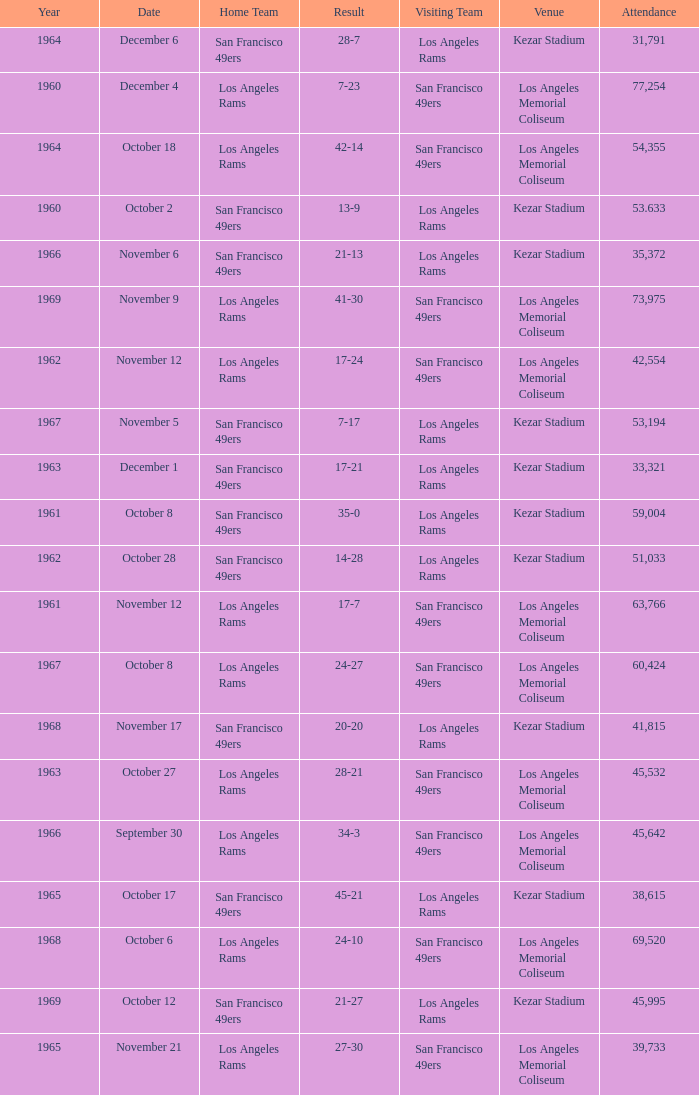When the san francisco 49ers are visiting with an attendance of more than 45,532 on September 30, who was the home team? Los Angeles Rams. Would you be able to parse every entry in this table? {'header': ['Year', 'Date', 'Home Team', 'Result', 'Visiting Team', 'Venue', 'Attendance'], 'rows': [['1964', 'December 6', 'San Francisco 49ers', '28-7', 'Los Angeles Rams', 'Kezar Stadium', '31,791'], ['1960', 'December 4', 'Los Angeles Rams', '7-23', 'San Francisco 49ers', 'Los Angeles Memorial Coliseum', '77,254'], ['1964', 'October 18', 'Los Angeles Rams', '42-14', 'San Francisco 49ers', 'Los Angeles Memorial Coliseum', '54,355'], ['1960', 'October 2', 'San Francisco 49ers', '13-9', 'Los Angeles Rams', 'Kezar Stadium', '53.633'], ['1966', 'November 6', 'San Francisco 49ers', '21-13', 'Los Angeles Rams', 'Kezar Stadium', '35,372'], ['1969', 'November 9', 'Los Angeles Rams', '41-30', 'San Francisco 49ers', 'Los Angeles Memorial Coliseum', '73,975'], ['1962', 'November 12', 'Los Angeles Rams', '17-24', 'San Francisco 49ers', 'Los Angeles Memorial Coliseum', '42,554'], ['1967', 'November 5', 'San Francisco 49ers', '7-17', 'Los Angeles Rams', 'Kezar Stadium', '53,194'], ['1963', 'December 1', 'San Francisco 49ers', '17-21', 'Los Angeles Rams', 'Kezar Stadium', '33,321'], ['1961', 'October 8', 'San Francisco 49ers', '35-0', 'Los Angeles Rams', 'Kezar Stadium', '59,004'], ['1962', 'October 28', 'San Francisco 49ers', '14-28', 'Los Angeles Rams', 'Kezar Stadium', '51,033'], ['1961', 'November 12', 'Los Angeles Rams', '17-7', 'San Francisco 49ers', 'Los Angeles Memorial Coliseum', '63,766'], ['1967', 'October 8', 'Los Angeles Rams', '24-27', 'San Francisco 49ers', 'Los Angeles Memorial Coliseum', '60,424'], ['1968', 'November 17', 'San Francisco 49ers', '20-20', 'Los Angeles Rams', 'Kezar Stadium', '41,815'], ['1963', 'October 27', 'Los Angeles Rams', '28-21', 'San Francisco 49ers', 'Los Angeles Memorial Coliseum', '45,532'], ['1966', 'September 30', 'Los Angeles Rams', '34-3', 'San Francisco 49ers', 'Los Angeles Memorial Coliseum', '45,642'], ['1965', 'October 17', 'San Francisco 49ers', '45-21', 'Los Angeles Rams', 'Kezar Stadium', '38,615'], ['1968', 'October 6', 'Los Angeles Rams', '24-10', 'San Francisco 49ers', 'Los Angeles Memorial Coliseum', '69,520'], ['1969', 'October 12', 'San Francisco 49ers', '21-27', 'Los Angeles Rams', 'Kezar Stadium', '45,995'], ['1965', 'November 21', 'Los Angeles Rams', '27-30', 'San Francisco 49ers', 'Los Angeles Memorial Coliseum', '39,733']]} 